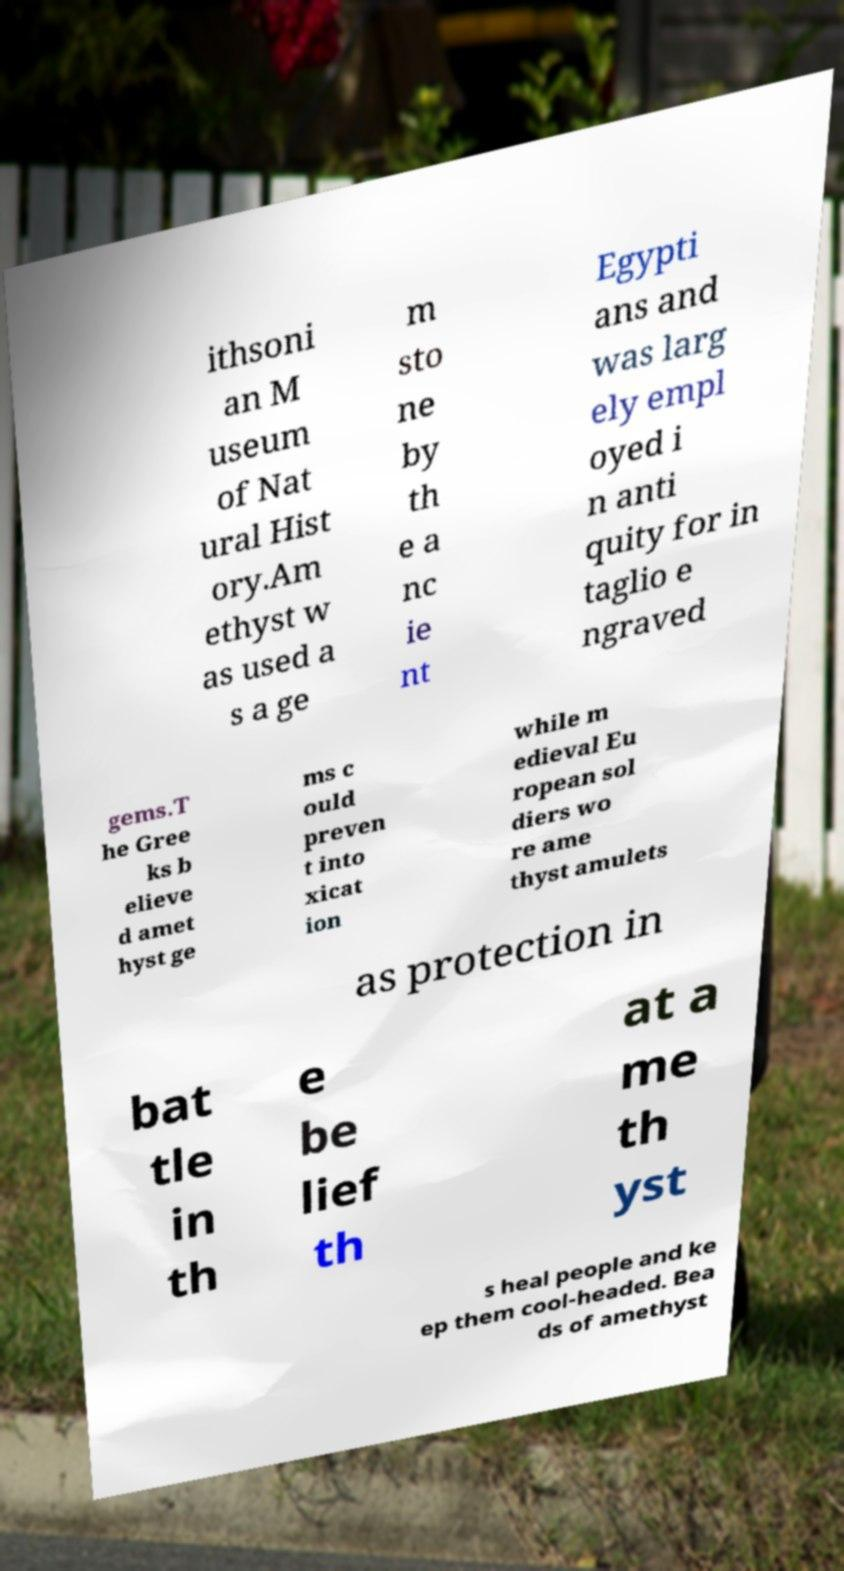There's text embedded in this image that I need extracted. Can you transcribe it verbatim? ithsoni an M useum of Nat ural Hist ory.Am ethyst w as used a s a ge m sto ne by th e a nc ie nt Egypti ans and was larg ely empl oyed i n anti quity for in taglio e ngraved gems.T he Gree ks b elieve d amet hyst ge ms c ould preven t into xicat ion while m edieval Eu ropean sol diers wo re ame thyst amulets as protection in bat tle in th e be lief th at a me th yst s heal people and ke ep them cool-headed. Bea ds of amethyst 